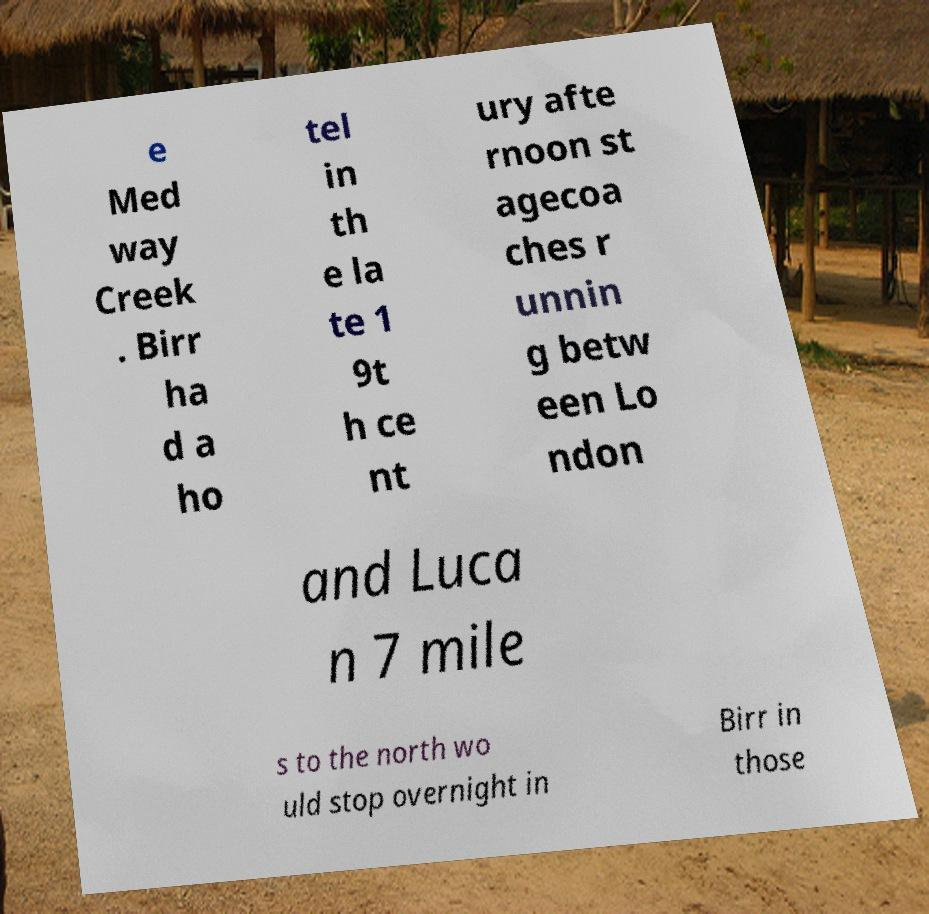Could you assist in decoding the text presented in this image and type it out clearly? e Med way Creek . Birr ha d a ho tel in th e la te 1 9t h ce nt ury afte rnoon st agecoa ches r unnin g betw een Lo ndon and Luca n 7 mile s to the north wo uld stop overnight in Birr in those 